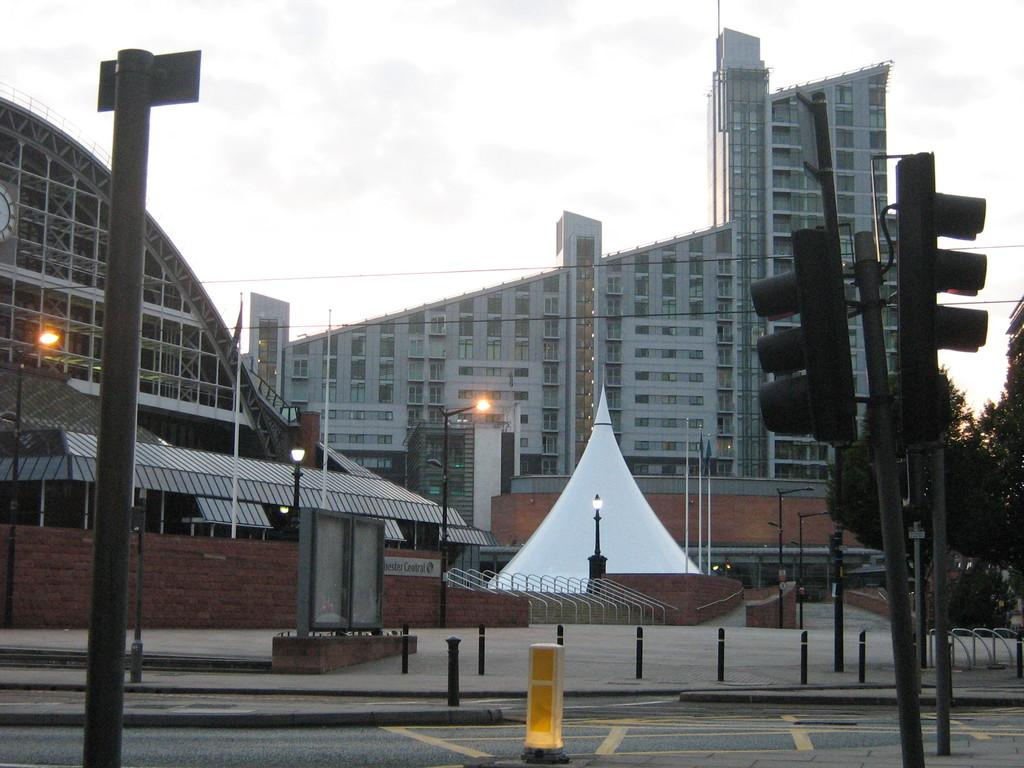What type of structures can be seen in the image? There are buildings in the image. What other natural or man-made elements are present in the image? There are trees and a traffic signal on a pole in the image. Are there any lighting fixtures visible in the image? Yes, there are pole lights in the image. How would you describe the weather based on the image? The sky is cloudy in the image. What else can be seen related to signaling or marking in the image? There are flagpoles in the image. Can you tell me how many tails are attached to the buildings in the image? There are no tails attached to the buildings in the image. Where is the drawer located in the image? There is no drawer present in the image. 